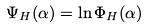Convert formula to latex. <formula><loc_0><loc_0><loc_500><loc_500>\Psi _ { H } ( \alpha ) = \ln \Phi _ { H } ( \alpha )</formula> 